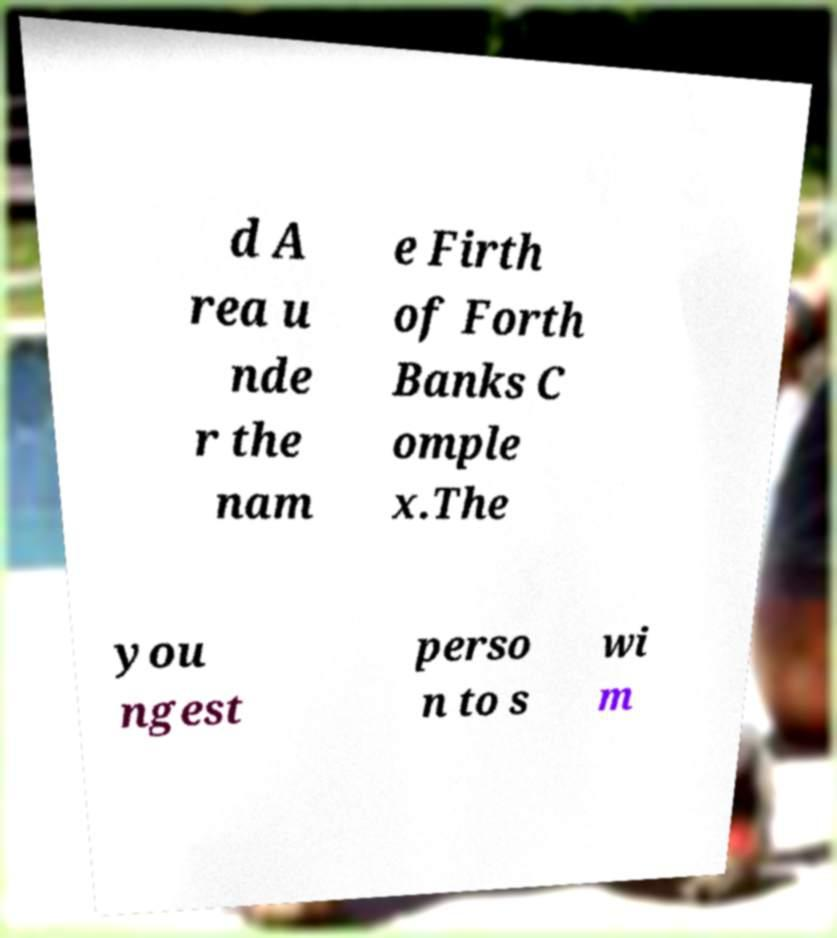Can you accurately transcribe the text from the provided image for me? d A rea u nde r the nam e Firth of Forth Banks C omple x.The you ngest perso n to s wi m 